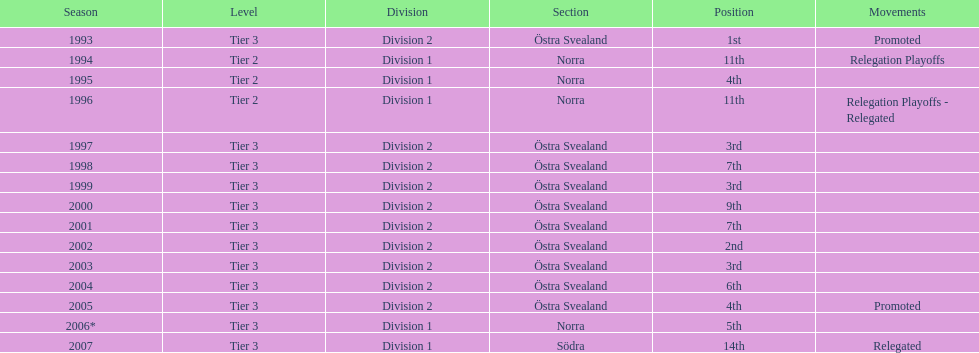How many times is division 2 listed as the division? 10. 